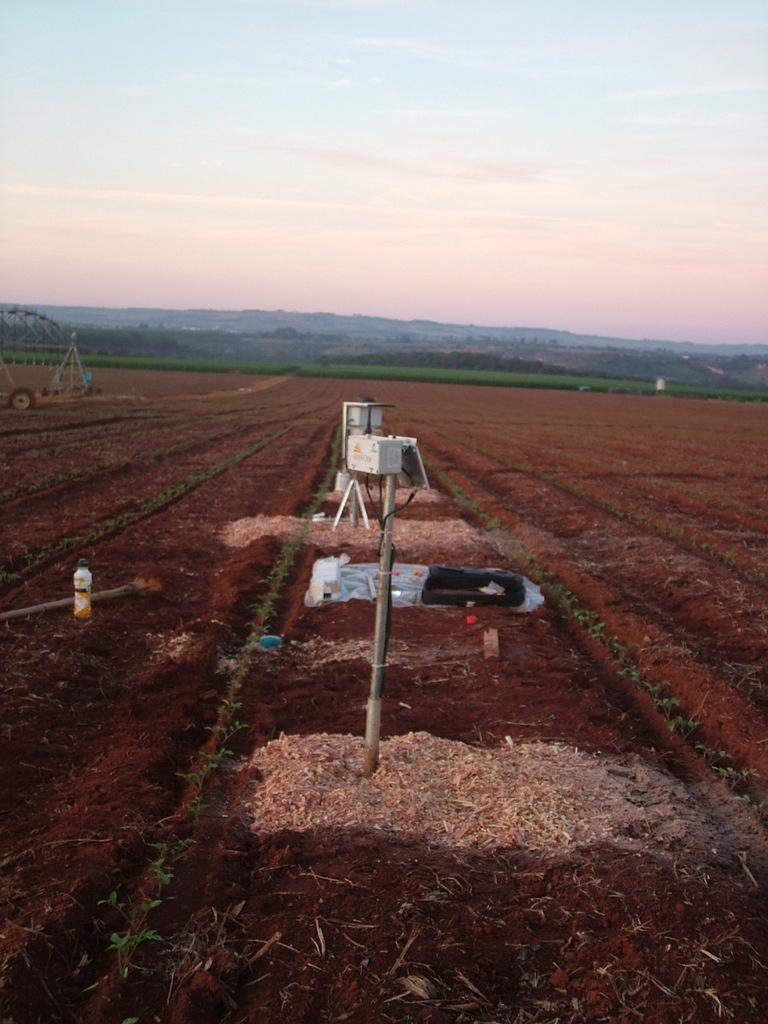What is located in the front of the image? In the front of the image, there is ground, poles, a bottle, and a wheel. Can you describe the objects in the front of the image? There are objects in the front of the image, including a bottle and a wheel. What can be seen in the background of the image? In the background of the image, there is greenery and sky visible. What type of cheese is being read in the image? There is no cheese or reading material present in the image. How many ears can be seen in the image? There are no ears visible in the image. 